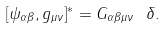Convert formula to latex. <formula><loc_0><loc_0><loc_500><loc_500>[ \psi _ { \alpha \beta } , g _ { \mu \nu } ] ^ { * } = G _ { \alpha \beta \mu \nu } \ \delta .</formula> 